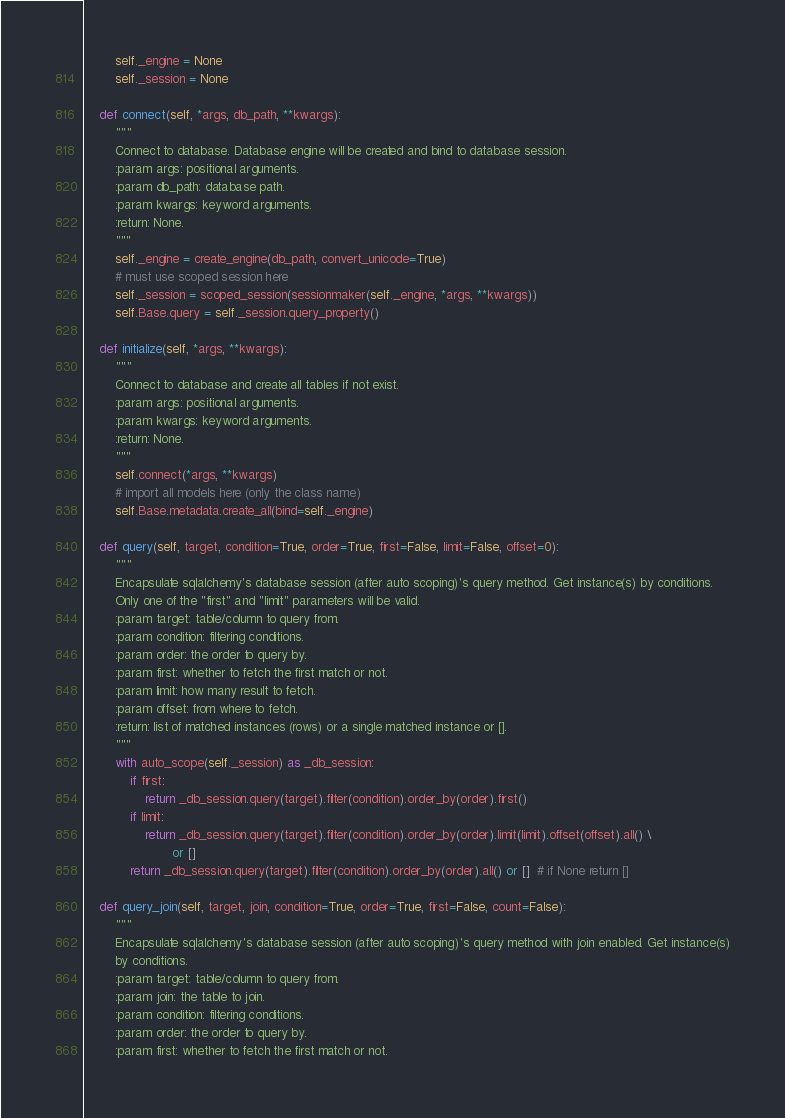<code> <loc_0><loc_0><loc_500><loc_500><_Python_>        self._engine = None
        self._session = None

    def connect(self, *args, db_path, **kwargs):
        """
        Connect to database. Database engine will be created and bind to database session.
        :param args: positional arguments.
        :param db_path: database path.
        :param kwargs: keyword arguments.
        :return: None.
        """
        self._engine = create_engine(db_path, convert_unicode=True)
        # must use scoped session here
        self._session = scoped_session(sessionmaker(self._engine, *args, **kwargs))
        self.Base.query = self._session.query_property()

    def initialize(self, *args, **kwargs):
        """
        Connect to database and create all tables if not exist.
        :param args: positional arguments.
        :param kwargs: keyword arguments.
        :return: None.
        """
        self.connect(*args, **kwargs)
        # import all models here (only the class name)
        self.Base.metadata.create_all(bind=self._engine)

    def query(self, target, condition=True, order=True, first=False, limit=False, offset=0):
        """
        Encapsulate sqlalchemy's database session (after auto scoping)'s query method. Get instance(s) by conditions.
        Only one of the "first" and "limit" parameters will be valid.
        :param target: table/column to query from.
        :param condition: filtering conditions.
        :param order: the order to query by.
        :param first: whether to fetch the first match or not.
        :param limit: how many result to fetch.
        :param offset: from where to fetch.
        :return: list of matched instances (rows) or a single matched instance or [].
        """
        with auto_scope(self._session) as _db_session:
            if first:
                return _db_session.query(target).filter(condition).order_by(order).first()
            if limit:
                return _db_session.query(target).filter(condition).order_by(order).limit(limit).offset(offset).all() \
                       or []
            return _db_session.query(target).filter(condition).order_by(order).all() or []  # if None return []

    def query_join(self, target, join, condition=True, order=True, first=False, count=False):
        """
        Encapsulate sqlalchemy's database session (after auto scoping)'s query method with join enabled. Get instance(s)
        by conditions.
        :param target: table/column to query from.
        :param join: the table to join.
        :param condition: filtering conditions.
        :param order: the order to query by.
        :param first: whether to fetch the first match or not.</code> 